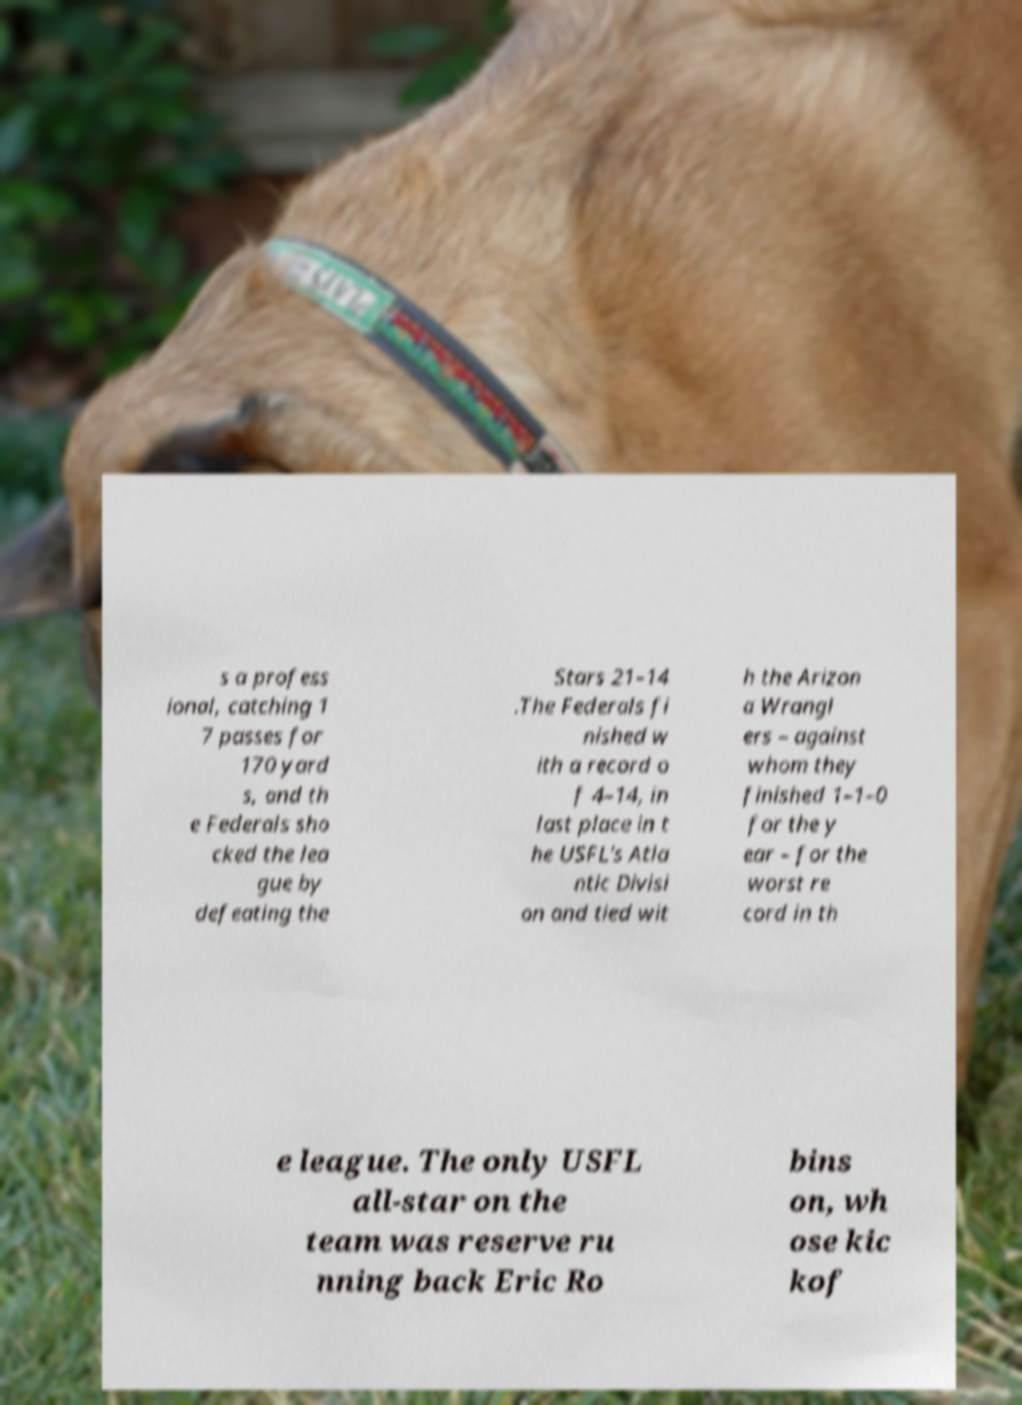There's text embedded in this image that I need extracted. Can you transcribe it verbatim? s a profess ional, catching 1 7 passes for 170 yard s, and th e Federals sho cked the lea gue by defeating the Stars 21–14 .The Federals fi nished w ith a record o f 4–14, in last place in t he USFL's Atla ntic Divisi on and tied wit h the Arizon a Wrangl ers – against whom they finished 1–1–0 for the y ear – for the worst re cord in th e league. The only USFL all-star on the team was reserve ru nning back Eric Ro bins on, wh ose kic kof 